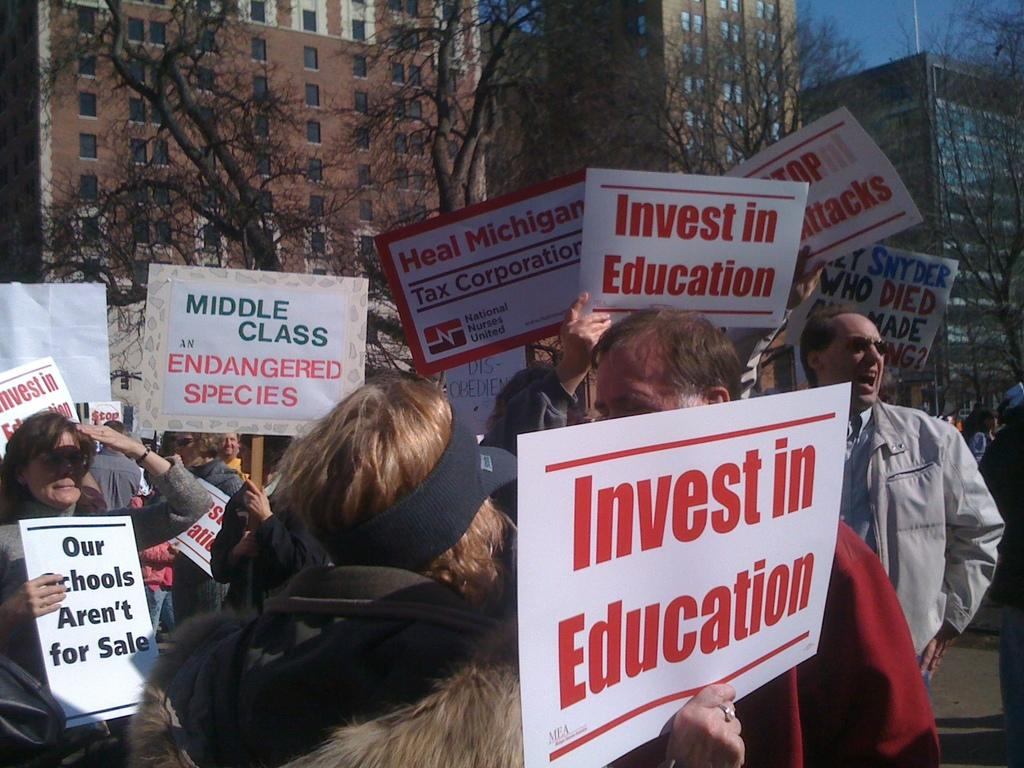What are the people in the image holding? The people in the image are holding boards with text. What can be seen in the background of the image? There are trees and buildings in the background of the image. What is visible in the sky in the image? The sky is visible in the image. How does the mother in the image feel about the comparison between gold and silver? There is no mother present in the image, nor is there any mention of a comparison between gold and silver. 